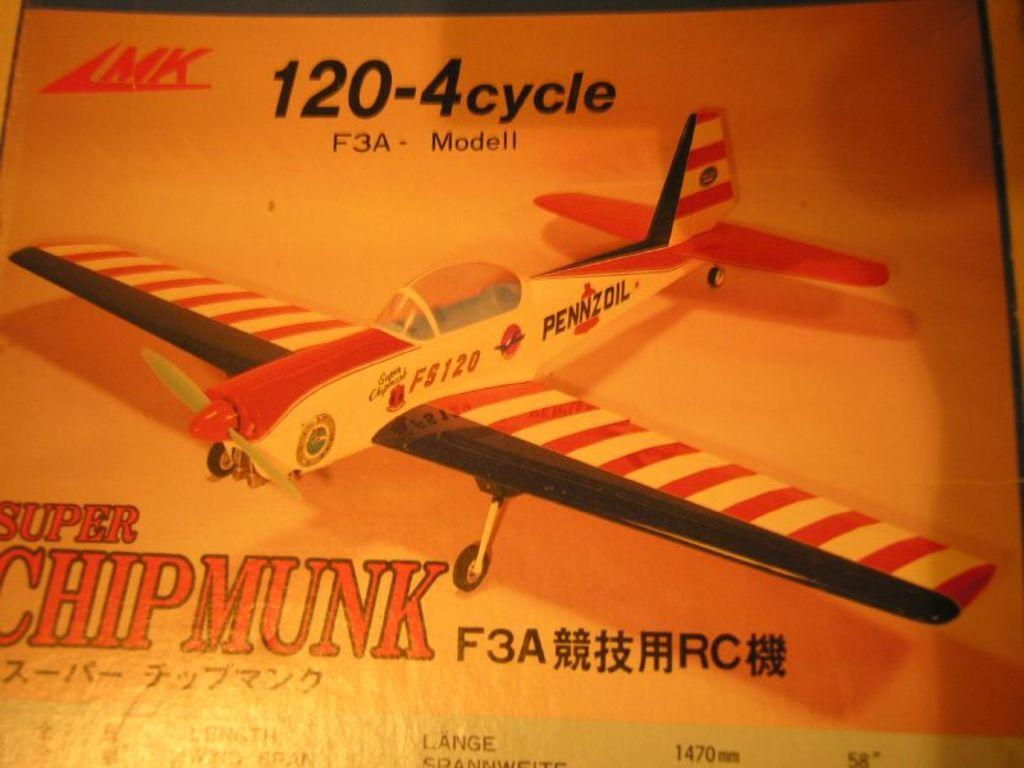What is present in the image? There is a poster in the image. What is depicted on the poster? The poster contains an image of an airplane. What type of basket is being used to play the guitar in the image? There is no basket or guitar present in the image; it only features a poster with an image of an airplane. 